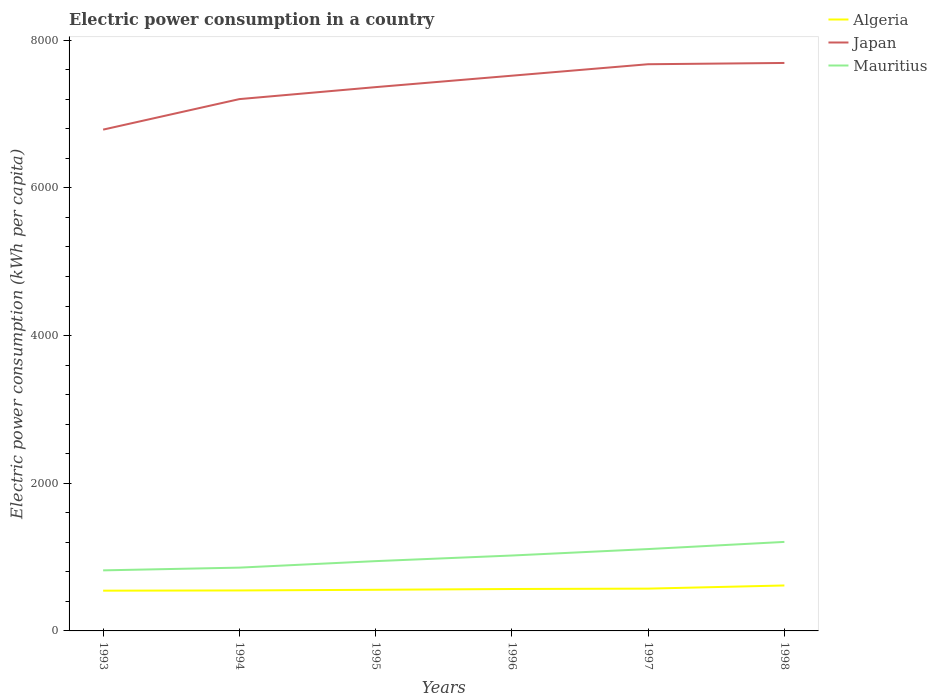Is the number of lines equal to the number of legend labels?
Your answer should be very brief. Yes. Across all years, what is the maximum electric power consumption in in Mauritius?
Your answer should be compact. 820.14. What is the total electric power consumption in in Algeria in the graph?
Ensure brevity in your answer.  -8.99. What is the difference between the highest and the second highest electric power consumption in in Mauritius?
Provide a succinct answer. 385.46. What is the difference between the highest and the lowest electric power consumption in in Japan?
Keep it short and to the point. 3. How many lines are there?
Ensure brevity in your answer.  3. How many years are there in the graph?
Ensure brevity in your answer.  6. Are the values on the major ticks of Y-axis written in scientific E-notation?
Offer a very short reply. No. Does the graph contain grids?
Keep it short and to the point. No. Where does the legend appear in the graph?
Offer a very short reply. Top right. How are the legend labels stacked?
Give a very brief answer. Vertical. What is the title of the graph?
Keep it short and to the point. Electric power consumption in a country. Does "Iceland" appear as one of the legend labels in the graph?
Give a very brief answer. No. What is the label or title of the Y-axis?
Offer a terse response. Electric power consumption (kWh per capita). What is the Electric power consumption (kWh per capita) in Algeria in 1993?
Provide a short and direct response. 545.02. What is the Electric power consumption (kWh per capita) of Japan in 1993?
Offer a very short reply. 6789.28. What is the Electric power consumption (kWh per capita) in Mauritius in 1993?
Provide a short and direct response. 820.14. What is the Electric power consumption (kWh per capita) in Algeria in 1994?
Your answer should be very brief. 548.09. What is the Electric power consumption (kWh per capita) of Japan in 1994?
Keep it short and to the point. 7202.58. What is the Electric power consumption (kWh per capita) in Mauritius in 1994?
Your response must be concise. 857.26. What is the Electric power consumption (kWh per capita) in Algeria in 1995?
Provide a short and direct response. 557.08. What is the Electric power consumption (kWh per capita) in Japan in 1995?
Your response must be concise. 7364.89. What is the Electric power consumption (kWh per capita) of Mauritius in 1995?
Ensure brevity in your answer.  945.25. What is the Electric power consumption (kWh per capita) of Algeria in 1996?
Your answer should be very brief. 567.7. What is the Electric power consumption (kWh per capita) in Japan in 1996?
Your response must be concise. 7519.65. What is the Electric power consumption (kWh per capita) in Mauritius in 1996?
Offer a terse response. 1021.17. What is the Electric power consumption (kWh per capita) of Algeria in 1997?
Offer a terse response. 572.91. What is the Electric power consumption (kWh per capita) in Japan in 1997?
Give a very brief answer. 7674.94. What is the Electric power consumption (kWh per capita) of Mauritius in 1997?
Ensure brevity in your answer.  1108.61. What is the Electric power consumption (kWh per capita) in Algeria in 1998?
Keep it short and to the point. 615.55. What is the Electric power consumption (kWh per capita) in Japan in 1998?
Keep it short and to the point. 7692.12. What is the Electric power consumption (kWh per capita) in Mauritius in 1998?
Your response must be concise. 1205.6. Across all years, what is the maximum Electric power consumption (kWh per capita) of Algeria?
Provide a short and direct response. 615.55. Across all years, what is the maximum Electric power consumption (kWh per capita) of Japan?
Give a very brief answer. 7692.12. Across all years, what is the maximum Electric power consumption (kWh per capita) of Mauritius?
Make the answer very short. 1205.6. Across all years, what is the minimum Electric power consumption (kWh per capita) in Algeria?
Provide a short and direct response. 545.02. Across all years, what is the minimum Electric power consumption (kWh per capita) of Japan?
Provide a short and direct response. 6789.28. Across all years, what is the minimum Electric power consumption (kWh per capita) in Mauritius?
Keep it short and to the point. 820.14. What is the total Electric power consumption (kWh per capita) in Algeria in the graph?
Offer a very short reply. 3406.36. What is the total Electric power consumption (kWh per capita) in Japan in the graph?
Keep it short and to the point. 4.42e+04. What is the total Electric power consumption (kWh per capita) of Mauritius in the graph?
Offer a very short reply. 5958.02. What is the difference between the Electric power consumption (kWh per capita) of Algeria in 1993 and that in 1994?
Offer a terse response. -3.07. What is the difference between the Electric power consumption (kWh per capita) in Japan in 1993 and that in 1994?
Offer a very short reply. -413.3. What is the difference between the Electric power consumption (kWh per capita) of Mauritius in 1993 and that in 1994?
Provide a succinct answer. -37.12. What is the difference between the Electric power consumption (kWh per capita) in Algeria in 1993 and that in 1995?
Your answer should be very brief. -12.06. What is the difference between the Electric power consumption (kWh per capita) in Japan in 1993 and that in 1995?
Offer a very short reply. -575.61. What is the difference between the Electric power consumption (kWh per capita) in Mauritius in 1993 and that in 1995?
Provide a succinct answer. -125.11. What is the difference between the Electric power consumption (kWh per capita) in Algeria in 1993 and that in 1996?
Make the answer very short. -22.67. What is the difference between the Electric power consumption (kWh per capita) in Japan in 1993 and that in 1996?
Your answer should be compact. -730.37. What is the difference between the Electric power consumption (kWh per capita) of Mauritius in 1993 and that in 1996?
Provide a short and direct response. -201.03. What is the difference between the Electric power consumption (kWh per capita) of Algeria in 1993 and that in 1997?
Ensure brevity in your answer.  -27.89. What is the difference between the Electric power consumption (kWh per capita) in Japan in 1993 and that in 1997?
Provide a short and direct response. -885.66. What is the difference between the Electric power consumption (kWh per capita) in Mauritius in 1993 and that in 1997?
Your response must be concise. -288.47. What is the difference between the Electric power consumption (kWh per capita) of Algeria in 1993 and that in 1998?
Your answer should be compact. -70.53. What is the difference between the Electric power consumption (kWh per capita) in Japan in 1993 and that in 1998?
Make the answer very short. -902.84. What is the difference between the Electric power consumption (kWh per capita) in Mauritius in 1993 and that in 1998?
Your answer should be compact. -385.46. What is the difference between the Electric power consumption (kWh per capita) in Algeria in 1994 and that in 1995?
Your response must be concise. -8.99. What is the difference between the Electric power consumption (kWh per capita) in Japan in 1994 and that in 1995?
Provide a short and direct response. -162.31. What is the difference between the Electric power consumption (kWh per capita) in Mauritius in 1994 and that in 1995?
Keep it short and to the point. -87.99. What is the difference between the Electric power consumption (kWh per capita) in Algeria in 1994 and that in 1996?
Provide a succinct answer. -19.6. What is the difference between the Electric power consumption (kWh per capita) of Japan in 1994 and that in 1996?
Offer a terse response. -317.07. What is the difference between the Electric power consumption (kWh per capita) of Mauritius in 1994 and that in 1996?
Provide a short and direct response. -163.91. What is the difference between the Electric power consumption (kWh per capita) of Algeria in 1994 and that in 1997?
Your response must be concise. -24.82. What is the difference between the Electric power consumption (kWh per capita) of Japan in 1994 and that in 1997?
Offer a terse response. -472.36. What is the difference between the Electric power consumption (kWh per capita) in Mauritius in 1994 and that in 1997?
Offer a very short reply. -251.35. What is the difference between the Electric power consumption (kWh per capita) of Algeria in 1994 and that in 1998?
Your response must be concise. -67.46. What is the difference between the Electric power consumption (kWh per capita) in Japan in 1994 and that in 1998?
Your answer should be compact. -489.54. What is the difference between the Electric power consumption (kWh per capita) of Mauritius in 1994 and that in 1998?
Your answer should be very brief. -348.34. What is the difference between the Electric power consumption (kWh per capita) of Algeria in 1995 and that in 1996?
Provide a short and direct response. -10.62. What is the difference between the Electric power consumption (kWh per capita) of Japan in 1995 and that in 1996?
Your answer should be compact. -154.76. What is the difference between the Electric power consumption (kWh per capita) of Mauritius in 1995 and that in 1996?
Provide a short and direct response. -75.92. What is the difference between the Electric power consumption (kWh per capita) of Algeria in 1995 and that in 1997?
Provide a short and direct response. -15.83. What is the difference between the Electric power consumption (kWh per capita) in Japan in 1995 and that in 1997?
Offer a very short reply. -310.05. What is the difference between the Electric power consumption (kWh per capita) in Mauritius in 1995 and that in 1997?
Offer a very short reply. -163.36. What is the difference between the Electric power consumption (kWh per capita) in Algeria in 1995 and that in 1998?
Offer a very short reply. -58.47. What is the difference between the Electric power consumption (kWh per capita) in Japan in 1995 and that in 1998?
Give a very brief answer. -327.23. What is the difference between the Electric power consumption (kWh per capita) of Mauritius in 1995 and that in 1998?
Offer a very short reply. -260.35. What is the difference between the Electric power consumption (kWh per capita) of Algeria in 1996 and that in 1997?
Offer a very short reply. -5.21. What is the difference between the Electric power consumption (kWh per capita) of Japan in 1996 and that in 1997?
Offer a very short reply. -155.29. What is the difference between the Electric power consumption (kWh per capita) of Mauritius in 1996 and that in 1997?
Keep it short and to the point. -87.44. What is the difference between the Electric power consumption (kWh per capita) of Algeria in 1996 and that in 1998?
Provide a succinct answer. -47.86. What is the difference between the Electric power consumption (kWh per capita) of Japan in 1996 and that in 1998?
Offer a terse response. -172.47. What is the difference between the Electric power consumption (kWh per capita) in Mauritius in 1996 and that in 1998?
Offer a terse response. -184.43. What is the difference between the Electric power consumption (kWh per capita) in Algeria in 1997 and that in 1998?
Offer a very short reply. -42.64. What is the difference between the Electric power consumption (kWh per capita) of Japan in 1997 and that in 1998?
Provide a short and direct response. -17.18. What is the difference between the Electric power consumption (kWh per capita) in Mauritius in 1997 and that in 1998?
Your answer should be very brief. -96.99. What is the difference between the Electric power consumption (kWh per capita) of Algeria in 1993 and the Electric power consumption (kWh per capita) of Japan in 1994?
Provide a short and direct response. -6657.56. What is the difference between the Electric power consumption (kWh per capita) of Algeria in 1993 and the Electric power consumption (kWh per capita) of Mauritius in 1994?
Provide a short and direct response. -312.24. What is the difference between the Electric power consumption (kWh per capita) in Japan in 1993 and the Electric power consumption (kWh per capita) in Mauritius in 1994?
Keep it short and to the point. 5932.02. What is the difference between the Electric power consumption (kWh per capita) in Algeria in 1993 and the Electric power consumption (kWh per capita) in Japan in 1995?
Make the answer very short. -6819.87. What is the difference between the Electric power consumption (kWh per capita) of Algeria in 1993 and the Electric power consumption (kWh per capita) of Mauritius in 1995?
Keep it short and to the point. -400.22. What is the difference between the Electric power consumption (kWh per capita) in Japan in 1993 and the Electric power consumption (kWh per capita) in Mauritius in 1995?
Offer a terse response. 5844.03. What is the difference between the Electric power consumption (kWh per capita) in Algeria in 1993 and the Electric power consumption (kWh per capita) in Japan in 1996?
Your answer should be compact. -6974.63. What is the difference between the Electric power consumption (kWh per capita) in Algeria in 1993 and the Electric power consumption (kWh per capita) in Mauritius in 1996?
Give a very brief answer. -476.14. What is the difference between the Electric power consumption (kWh per capita) in Japan in 1993 and the Electric power consumption (kWh per capita) in Mauritius in 1996?
Offer a terse response. 5768.11. What is the difference between the Electric power consumption (kWh per capita) in Algeria in 1993 and the Electric power consumption (kWh per capita) in Japan in 1997?
Keep it short and to the point. -7129.92. What is the difference between the Electric power consumption (kWh per capita) in Algeria in 1993 and the Electric power consumption (kWh per capita) in Mauritius in 1997?
Provide a succinct answer. -563.59. What is the difference between the Electric power consumption (kWh per capita) of Japan in 1993 and the Electric power consumption (kWh per capita) of Mauritius in 1997?
Ensure brevity in your answer.  5680.67. What is the difference between the Electric power consumption (kWh per capita) in Algeria in 1993 and the Electric power consumption (kWh per capita) in Japan in 1998?
Make the answer very short. -7147.1. What is the difference between the Electric power consumption (kWh per capita) of Algeria in 1993 and the Electric power consumption (kWh per capita) of Mauritius in 1998?
Offer a very short reply. -660.57. What is the difference between the Electric power consumption (kWh per capita) in Japan in 1993 and the Electric power consumption (kWh per capita) in Mauritius in 1998?
Make the answer very short. 5583.68. What is the difference between the Electric power consumption (kWh per capita) in Algeria in 1994 and the Electric power consumption (kWh per capita) in Japan in 1995?
Give a very brief answer. -6816.8. What is the difference between the Electric power consumption (kWh per capita) in Algeria in 1994 and the Electric power consumption (kWh per capita) in Mauritius in 1995?
Make the answer very short. -397.16. What is the difference between the Electric power consumption (kWh per capita) in Japan in 1994 and the Electric power consumption (kWh per capita) in Mauritius in 1995?
Your answer should be compact. 6257.34. What is the difference between the Electric power consumption (kWh per capita) in Algeria in 1994 and the Electric power consumption (kWh per capita) in Japan in 1996?
Make the answer very short. -6971.56. What is the difference between the Electric power consumption (kWh per capita) in Algeria in 1994 and the Electric power consumption (kWh per capita) in Mauritius in 1996?
Your response must be concise. -473.08. What is the difference between the Electric power consumption (kWh per capita) of Japan in 1994 and the Electric power consumption (kWh per capita) of Mauritius in 1996?
Make the answer very short. 6181.42. What is the difference between the Electric power consumption (kWh per capita) of Algeria in 1994 and the Electric power consumption (kWh per capita) of Japan in 1997?
Provide a short and direct response. -7126.85. What is the difference between the Electric power consumption (kWh per capita) of Algeria in 1994 and the Electric power consumption (kWh per capita) of Mauritius in 1997?
Make the answer very short. -560.52. What is the difference between the Electric power consumption (kWh per capita) in Japan in 1994 and the Electric power consumption (kWh per capita) in Mauritius in 1997?
Offer a very short reply. 6093.97. What is the difference between the Electric power consumption (kWh per capita) in Algeria in 1994 and the Electric power consumption (kWh per capita) in Japan in 1998?
Offer a terse response. -7144.03. What is the difference between the Electric power consumption (kWh per capita) of Algeria in 1994 and the Electric power consumption (kWh per capita) of Mauritius in 1998?
Offer a very short reply. -657.5. What is the difference between the Electric power consumption (kWh per capita) of Japan in 1994 and the Electric power consumption (kWh per capita) of Mauritius in 1998?
Ensure brevity in your answer.  5996.99. What is the difference between the Electric power consumption (kWh per capita) of Algeria in 1995 and the Electric power consumption (kWh per capita) of Japan in 1996?
Your answer should be compact. -6962.57. What is the difference between the Electric power consumption (kWh per capita) of Algeria in 1995 and the Electric power consumption (kWh per capita) of Mauritius in 1996?
Make the answer very short. -464.09. What is the difference between the Electric power consumption (kWh per capita) of Japan in 1995 and the Electric power consumption (kWh per capita) of Mauritius in 1996?
Your response must be concise. 6343.73. What is the difference between the Electric power consumption (kWh per capita) of Algeria in 1995 and the Electric power consumption (kWh per capita) of Japan in 1997?
Offer a very short reply. -7117.86. What is the difference between the Electric power consumption (kWh per capita) of Algeria in 1995 and the Electric power consumption (kWh per capita) of Mauritius in 1997?
Your answer should be compact. -551.53. What is the difference between the Electric power consumption (kWh per capita) of Japan in 1995 and the Electric power consumption (kWh per capita) of Mauritius in 1997?
Offer a terse response. 6256.28. What is the difference between the Electric power consumption (kWh per capita) in Algeria in 1995 and the Electric power consumption (kWh per capita) in Japan in 1998?
Your answer should be very brief. -7135.04. What is the difference between the Electric power consumption (kWh per capita) of Algeria in 1995 and the Electric power consumption (kWh per capita) of Mauritius in 1998?
Provide a succinct answer. -648.52. What is the difference between the Electric power consumption (kWh per capita) in Japan in 1995 and the Electric power consumption (kWh per capita) in Mauritius in 1998?
Ensure brevity in your answer.  6159.3. What is the difference between the Electric power consumption (kWh per capita) in Algeria in 1996 and the Electric power consumption (kWh per capita) in Japan in 1997?
Ensure brevity in your answer.  -7107.24. What is the difference between the Electric power consumption (kWh per capita) in Algeria in 1996 and the Electric power consumption (kWh per capita) in Mauritius in 1997?
Give a very brief answer. -540.91. What is the difference between the Electric power consumption (kWh per capita) of Japan in 1996 and the Electric power consumption (kWh per capita) of Mauritius in 1997?
Keep it short and to the point. 6411.04. What is the difference between the Electric power consumption (kWh per capita) of Algeria in 1996 and the Electric power consumption (kWh per capita) of Japan in 1998?
Give a very brief answer. -7124.42. What is the difference between the Electric power consumption (kWh per capita) of Algeria in 1996 and the Electric power consumption (kWh per capita) of Mauritius in 1998?
Make the answer very short. -637.9. What is the difference between the Electric power consumption (kWh per capita) in Japan in 1996 and the Electric power consumption (kWh per capita) in Mauritius in 1998?
Make the answer very short. 6314.06. What is the difference between the Electric power consumption (kWh per capita) in Algeria in 1997 and the Electric power consumption (kWh per capita) in Japan in 1998?
Offer a very short reply. -7119.21. What is the difference between the Electric power consumption (kWh per capita) in Algeria in 1997 and the Electric power consumption (kWh per capita) in Mauritius in 1998?
Ensure brevity in your answer.  -632.69. What is the difference between the Electric power consumption (kWh per capita) of Japan in 1997 and the Electric power consumption (kWh per capita) of Mauritius in 1998?
Ensure brevity in your answer.  6469.34. What is the average Electric power consumption (kWh per capita) in Algeria per year?
Keep it short and to the point. 567.73. What is the average Electric power consumption (kWh per capita) of Japan per year?
Offer a terse response. 7373.91. What is the average Electric power consumption (kWh per capita) of Mauritius per year?
Give a very brief answer. 993. In the year 1993, what is the difference between the Electric power consumption (kWh per capita) of Algeria and Electric power consumption (kWh per capita) of Japan?
Ensure brevity in your answer.  -6244.26. In the year 1993, what is the difference between the Electric power consumption (kWh per capita) in Algeria and Electric power consumption (kWh per capita) in Mauritius?
Provide a short and direct response. -275.12. In the year 1993, what is the difference between the Electric power consumption (kWh per capita) of Japan and Electric power consumption (kWh per capita) of Mauritius?
Give a very brief answer. 5969.14. In the year 1994, what is the difference between the Electric power consumption (kWh per capita) in Algeria and Electric power consumption (kWh per capita) in Japan?
Provide a short and direct response. -6654.49. In the year 1994, what is the difference between the Electric power consumption (kWh per capita) of Algeria and Electric power consumption (kWh per capita) of Mauritius?
Keep it short and to the point. -309.17. In the year 1994, what is the difference between the Electric power consumption (kWh per capita) of Japan and Electric power consumption (kWh per capita) of Mauritius?
Give a very brief answer. 6345.32. In the year 1995, what is the difference between the Electric power consumption (kWh per capita) in Algeria and Electric power consumption (kWh per capita) in Japan?
Your answer should be very brief. -6807.81. In the year 1995, what is the difference between the Electric power consumption (kWh per capita) of Algeria and Electric power consumption (kWh per capita) of Mauritius?
Give a very brief answer. -388.17. In the year 1995, what is the difference between the Electric power consumption (kWh per capita) in Japan and Electric power consumption (kWh per capita) in Mauritius?
Your answer should be very brief. 6419.65. In the year 1996, what is the difference between the Electric power consumption (kWh per capita) in Algeria and Electric power consumption (kWh per capita) in Japan?
Provide a short and direct response. -6951.96. In the year 1996, what is the difference between the Electric power consumption (kWh per capita) of Algeria and Electric power consumption (kWh per capita) of Mauritius?
Offer a very short reply. -453.47. In the year 1996, what is the difference between the Electric power consumption (kWh per capita) in Japan and Electric power consumption (kWh per capita) in Mauritius?
Keep it short and to the point. 6498.49. In the year 1997, what is the difference between the Electric power consumption (kWh per capita) in Algeria and Electric power consumption (kWh per capita) in Japan?
Keep it short and to the point. -7102.03. In the year 1997, what is the difference between the Electric power consumption (kWh per capita) in Algeria and Electric power consumption (kWh per capita) in Mauritius?
Ensure brevity in your answer.  -535.7. In the year 1997, what is the difference between the Electric power consumption (kWh per capita) in Japan and Electric power consumption (kWh per capita) in Mauritius?
Give a very brief answer. 6566.33. In the year 1998, what is the difference between the Electric power consumption (kWh per capita) of Algeria and Electric power consumption (kWh per capita) of Japan?
Keep it short and to the point. -7076.57. In the year 1998, what is the difference between the Electric power consumption (kWh per capita) of Algeria and Electric power consumption (kWh per capita) of Mauritius?
Offer a terse response. -590.04. In the year 1998, what is the difference between the Electric power consumption (kWh per capita) in Japan and Electric power consumption (kWh per capita) in Mauritius?
Keep it short and to the point. 6486.52. What is the ratio of the Electric power consumption (kWh per capita) in Japan in 1993 to that in 1994?
Your response must be concise. 0.94. What is the ratio of the Electric power consumption (kWh per capita) of Mauritius in 1993 to that in 1994?
Offer a terse response. 0.96. What is the ratio of the Electric power consumption (kWh per capita) in Algeria in 1993 to that in 1995?
Offer a terse response. 0.98. What is the ratio of the Electric power consumption (kWh per capita) of Japan in 1993 to that in 1995?
Provide a short and direct response. 0.92. What is the ratio of the Electric power consumption (kWh per capita) of Mauritius in 1993 to that in 1995?
Give a very brief answer. 0.87. What is the ratio of the Electric power consumption (kWh per capita) in Algeria in 1993 to that in 1996?
Provide a short and direct response. 0.96. What is the ratio of the Electric power consumption (kWh per capita) of Japan in 1993 to that in 1996?
Keep it short and to the point. 0.9. What is the ratio of the Electric power consumption (kWh per capita) in Mauritius in 1993 to that in 1996?
Offer a very short reply. 0.8. What is the ratio of the Electric power consumption (kWh per capita) in Algeria in 1993 to that in 1997?
Keep it short and to the point. 0.95. What is the ratio of the Electric power consumption (kWh per capita) of Japan in 1993 to that in 1997?
Offer a terse response. 0.88. What is the ratio of the Electric power consumption (kWh per capita) of Mauritius in 1993 to that in 1997?
Offer a terse response. 0.74. What is the ratio of the Electric power consumption (kWh per capita) of Algeria in 1993 to that in 1998?
Give a very brief answer. 0.89. What is the ratio of the Electric power consumption (kWh per capita) in Japan in 1993 to that in 1998?
Your answer should be very brief. 0.88. What is the ratio of the Electric power consumption (kWh per capita) of Mauritius in 1993 to that in 1998?
Your response must be concise. 0.68. What is the ratio of the Electric power consumption (kWh per capita) in Algeria in 1994 to that in 1995?
Offer a terse response. 0.98. What is the ratio of the Electric power consumption (kWh per capita) in Japan in 1994 to that in 1995?
Provide a short and direct response. 0.98. What is the ratio of the Electric power consumption (kWh per capita) in Mauritius in 1994 to that in 1995?
Make the answer very short. 0.91. What is the ratio of the Electric power consumption (kWh per capita) of Algeria in 1994 to that in 1996?
Your response must be concise. 0.97. What is the ratio of the Electric power consumption (kWh per capita) of Japan in 1994 to that in 1996?
Ensure brevity in your answer.  0.96. What is the ratio of the Electric power consumption (kWh per capita) in Mauritius in 1994 to that in 1996?
Provide a succinct answer. 0.84. What is the ratio of the Electric power consumption (kWh per capita) of Algeria in 1994 to that in 1997?
Offer a terse response. 0.96. What is the ratio of the Electric power consumption (kWh per capita) in Japan in 1994 to that in 1997?
Your answer should be compact. 0.94. What is the ratio of the Electric power consumption (kWh per capita) in Mauritius in 1994 to that in 1997?
Ensure brevity in your answer.  0.77. What is the ratio of the Electric power consumption (kWh per capita) of Algeria in 1994 to that in 1998?
Ensure brevity in your answer.  0.89. What is the ratio of the Electric power consumption (kWh per capita) of Japan in 1994 to that in 1998?
Offer a very short reply. 0.94. What is the ratio of the Electric power consumption (kWh per capita) of Mauritius in 1994 to that in 1998?
Provide a short and direct response. 0.71. What is the ratio of the Electric power consumption (kWh per capita) in Algeria in 1995 to that in 1996?
Offer a very short reply. 0.98. What is the ratio of the Electric power consumption (kWh per capita) of Japan in 1995 to that in 1996?
Your answer should be very brief. 0.98. What is the ratio of the Electric power consumption (kWh per capita) in Mauritius in 1995 to that in 1996?
Offer a terse response. 0.93. What is the ratio of the Electric power consumption (kWh per capita) of Algeria in 1995 to that in 1997?
Your answer should be compact. 0.97. What is the ratio of the Electric power consumption (kWh per capita) of Japan in 1995 to that in 1997?
Provide a short and direct response. 0.96. What is the ratio of the Electric power consumption (kWh per capita) of Mauritius in 1995 to that in 1997?
Your response must be concise. 0.85. What is the ratio of the Electric power consumption (kWh per capita) in Algeria in 1995 to that in 1998?
Ensure brevity in your answer.  0.91. What is the ratio of the Electric power consumption (kWh per capita) in Japan in 1995 to that in 1998?
Offer a terse response. 0.96. What is the ratio of the Electric power consumption (kWh per capita) in Mauritius in 1995 to that in 1998?
Offer a very short reply. 0.78. What is the ratio of the Electric power consumption (kWh per capita) of Algeria in 1996 to that in 1997?
Offer a terse response. 0.99. What is the ratio of the Electric power consumption (kWh per capita) of Japan in 1996 to that in 1997?
Provide a succinct answer. 0.98. What is the ratio of the Electric power consumption (kWh per capita) of Mauritius in 1996 to that in 1997?
Keep it short and to the point. 0.92. What is the ratio of the Electric power consumption (kWh per capita) of Algeria in 1996 to that in 1998?
Offer a terse response. 0.92. What is the ratio of the Electric power consumption (kWh per capita) in Japan in 1996 to that in 1998?
Give a very brief answer. 0.98. What is the ratio of the Electric power consumption (kWh per capita) of Mauritius in 1996 to that in 1998?
Your answer should be compact. 0.85. What is the ratio of the Electric power consumption (kWh per capita) in Algeria in 1997 to that in 1998?
Provide a succinct answer. 0.93. What is the ratio of the Electric power consumption (kWh per capita) of Japan in 1997 to that in 1998?
Give a very brief answer. 1. What is the ratio of the Electric power consumption (kWh per capita) in Mauritius in 1997 to that in 1998?
Your answer should be compact. 0.92. What is the difference between the highest and the second highest Electric power consumption (kWh per capita) in Algeria?
Provide a short and direct response. 42.64. What is the difference between the highest and the second highest Electric power consumption (kWh per capita) in Japan?
Ensure brevity in your answer.  17.18. What is the difference between the highest and the second highest Electric power consumption (kWh per capita) of Mauritius?
Offer a very short reply. 96.99. What is the difference between the highest and the lowest Electric power consumption (kWh per capita) of Algeria?
Keep it short and to the point. 70.53. What is the difference between the highest and the lowest Electric power consumption (kWh per capita) in Japan?
Offer a terse response. 902.84. What is the difference between the highest and the lowest Electric power consumption (kWh per capita) in Mauritius?
Provide a succinct answer. 385.46. 